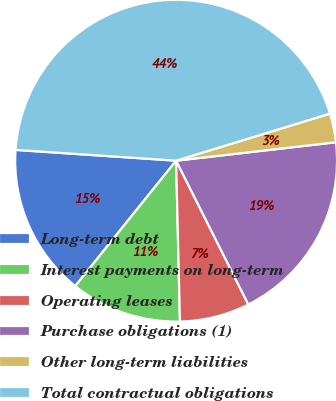<chart> <loc_0><loc_0><loc_500><loc_500><pie_chart><fcel>Long-term debt<fcel>Interest payments on long-term<fcel>Operating leases<fcel>Purchase obligations (1)<fcel>Other long-term liabilities<fcel>Total contractual obligations<nl><fcel>15.29%<fcel>11.16%<fcel>7.03%<fcel>19.42%<fcel>2.9%<fcel>44.21%<nl></chart> 